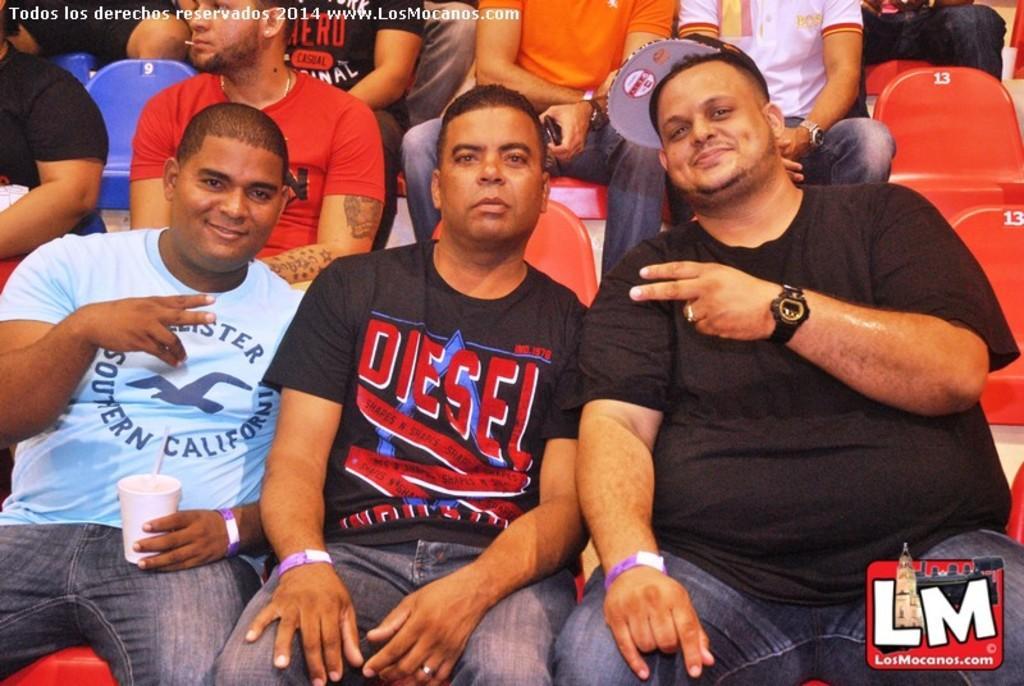Can you describe this image briefly? These people are sitting on chairs. This man is holding a cup. Left side top of the image there is a watermark. 